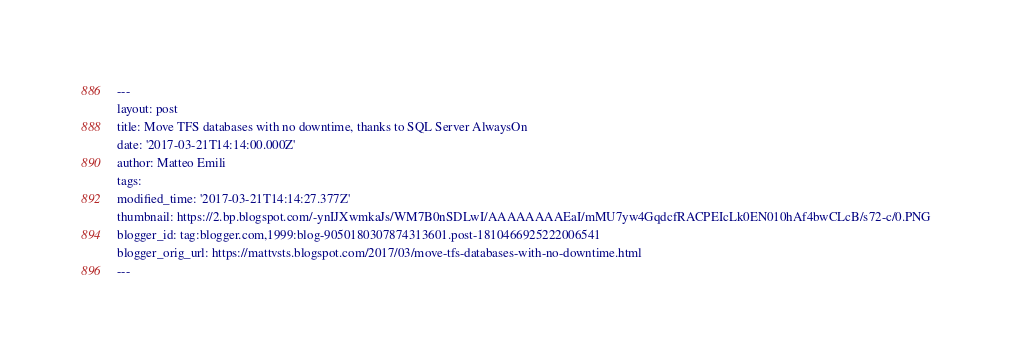<code> <loc_0><loc_0><loc_500><loc_500><_HTML_>---
layout: post
title: Move TFS databases with no downtime, thanks to SQL Server AlwaysOn
date: '2017-03-21T14:14:00.000Z'
author: Matteo Emili
tags: 
modified_time: '2017-03-21T14:14:27.377Z'
thumbnail: https://2.bp.blogspot.com/-ynIJXwmkaJs/WM7B0nSDLwI/AAAAAAAAEaI/mMU7yw4GqdcfRACPEIcLk0EN010hAf4bwCLcB/s72-c/0.PNG
blogger_id: tag:blogger.com,1999:blog-9050180307874313601.post-1810466925222006541
blogger_orig_url: https://mattvsts.blogspot.com/2017/03/move-tfs-databases-with-no-downtime.html
---
</code> 